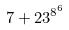Convert formula to latex. <formula><loc_0><loc_0><loc_500><loc_500>7 + 2 3 ^ { 8 ^ { 6 } }</formula> 